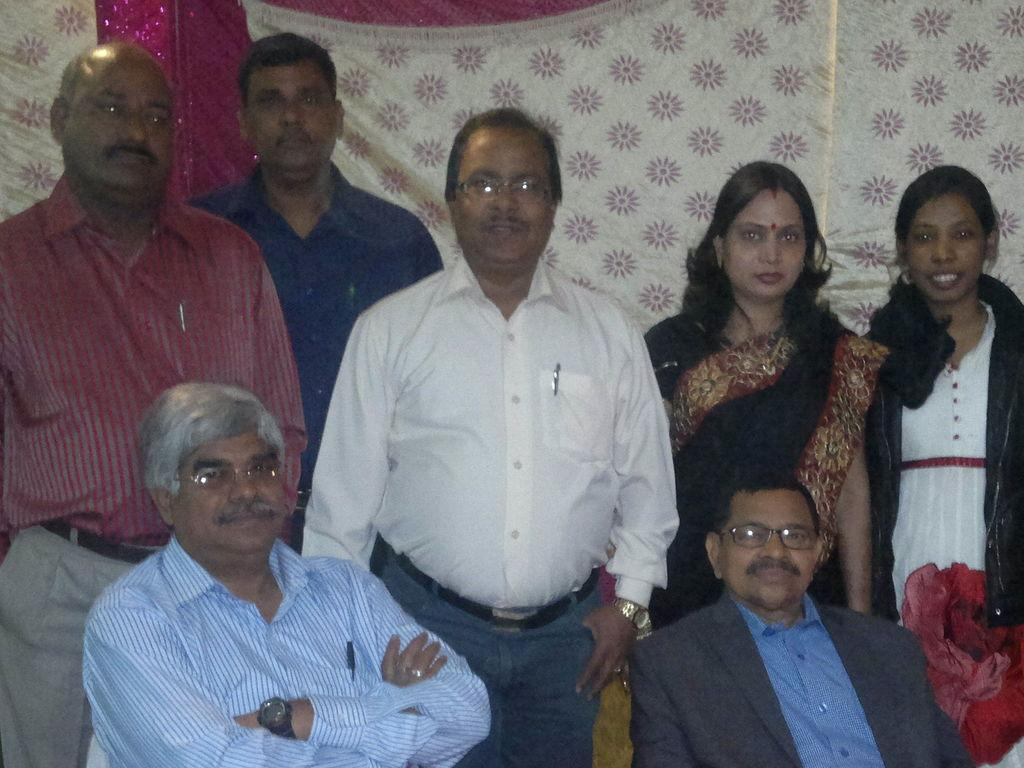What is the primary activity of the people in the image? The people in the image are either standing or sitting. Can you describe the positions of the people in the image? Some of the people are standing, while others are sitting. What is visible in the background of the image? There is a curtain visible in the background of the image. What type of summer activity are the people participating in the image? The image does not provide any information about a summer activity; it simply shows people standing or sitting. Can you see any sand in the image? There is no sand visible in the image. Is there a rod being used by any of the people in the image? There is no rod present in the image. 